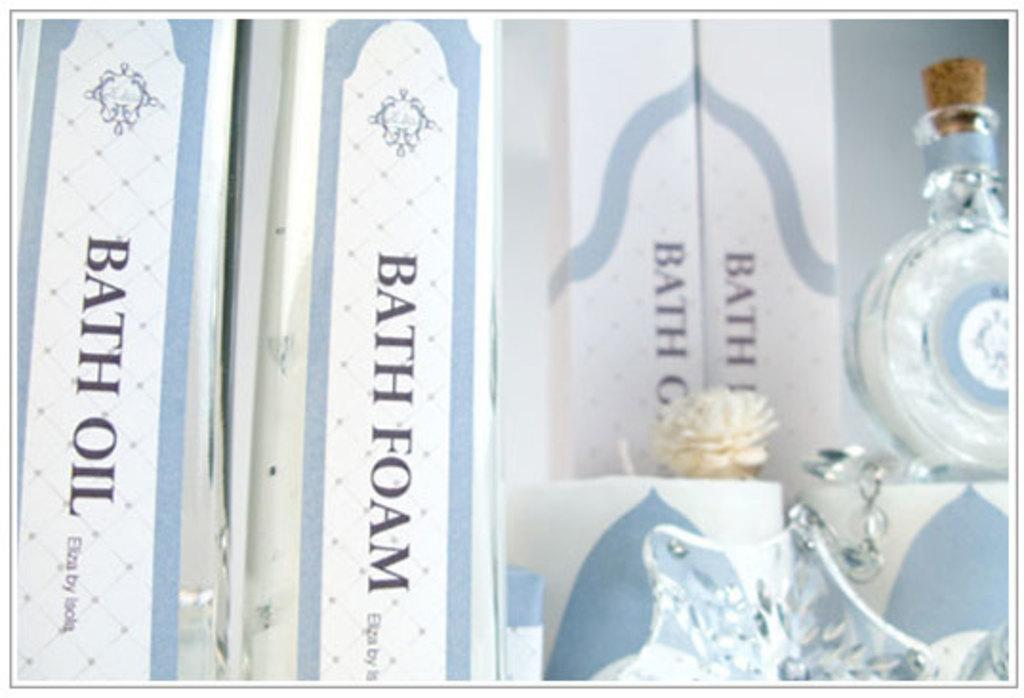<image>
Relay a brief, clear account of the picture shown. Some bath products including bath oil and bath foam. 